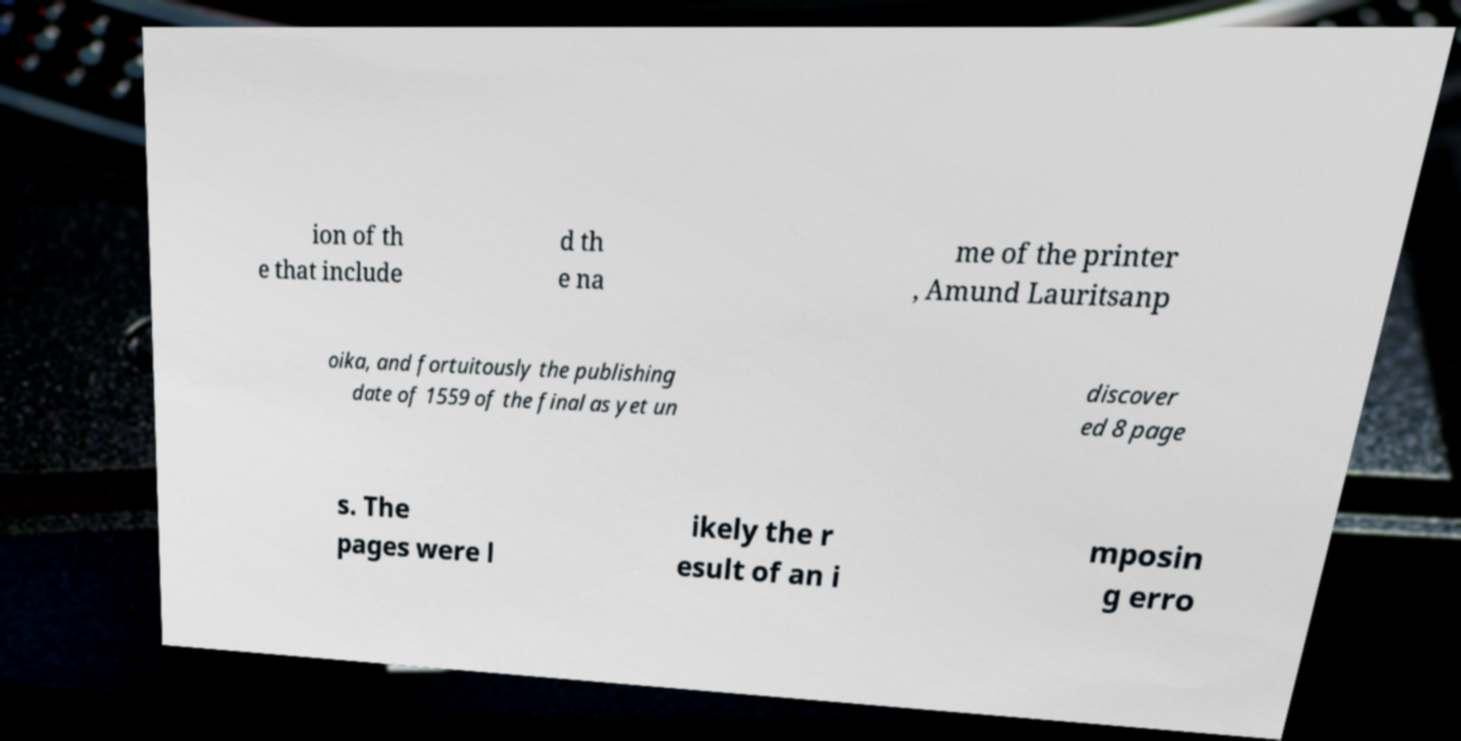Could you assist in decoding the text presented in this image and type it out clearly? ion of th e that include d th e na me of the printer , Amund Lauritsanp oika, and fortuitously the publishing date of 1559 of the final as yet un discover ed 8 page s. The pages were l ikely the r esult of an i mposin g erro 